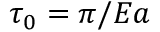Convert formula to latex. <formula><loc_0><loc_0><loc_500><loc_500>\tau _ { 0 } = \pi / E a</formula> 